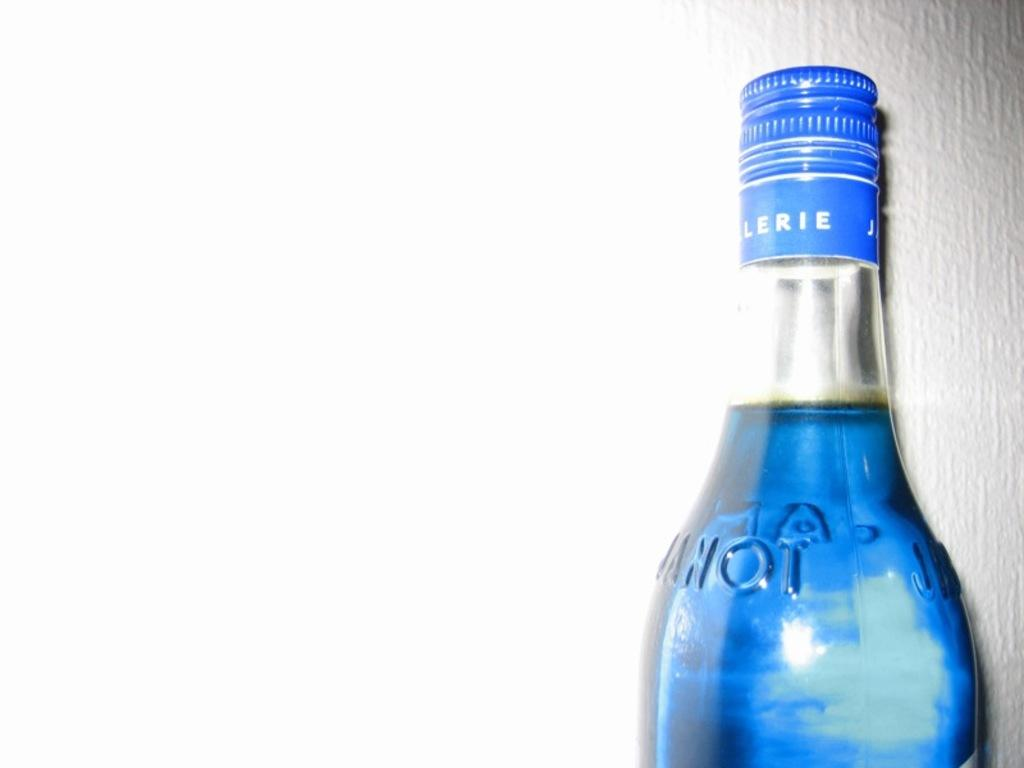Provide a one-sentence caption for the provided image. A bottle with a blue top with LERIE written on it. 